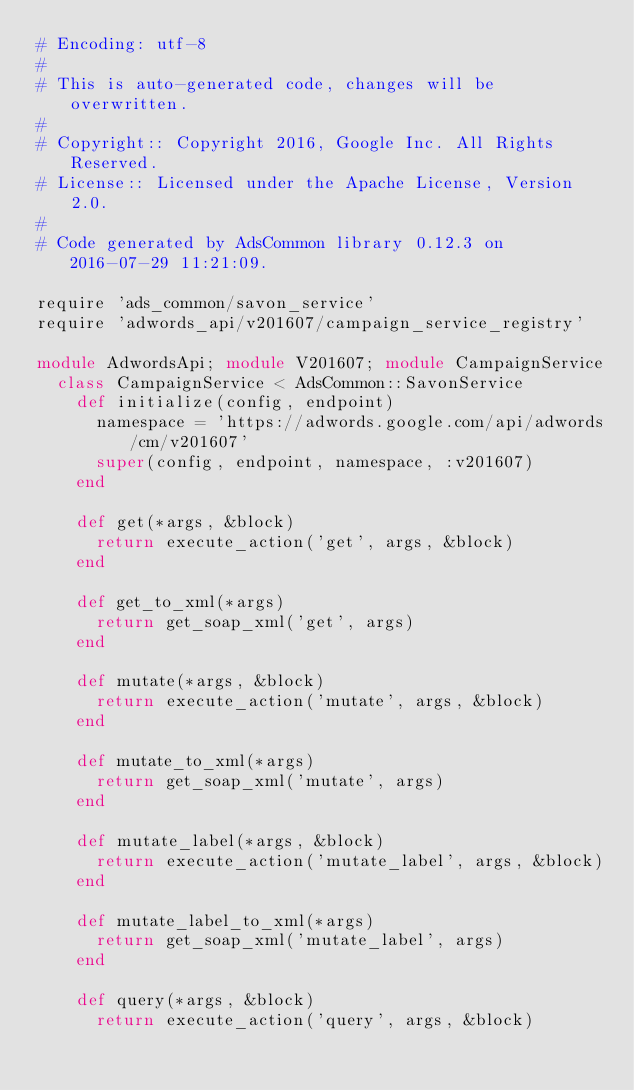<code> <loc_0><loc_0><loc_500><loc_500><_Ruby_># Encoding: utf-8
#
# This is auto-generated code, changes will be overwritten.
#
# Copyright:: Copyright 2016, Google Inc. All Rights Reserved.
# License:: Licensed under the Apache License, Version 2.0.
#
# Code generated by AdsCommon library 0.12.3 on 2016-07-29 11:21:09.

require 'ads_common/savon_service'
require 'adwords_api/v201607/campaign_service_registry'

module AdwordsApi; module V201607; module CampaignService
  class CampaignService < AdsCommon::SavonService
    def initialize(config, endpoint)
      namespace = 'https://adwords.google.com/api/adwords/cm/v201607'
      super(config, endpoint, namespace, :v201607)
    end

    def get(*args, &block)
      return execute_action('get', args, &block)
    end

    def get_to_xml(*args)
      return get_soap_xml('get', args)
    end

    def mutate(*args, &block)
      return execute_action('mutate', args, &block)
    end

    def mutate_to_xml(*args)
      return get_soap_xml('mutate', args)
    end

    def mutate_label(*args, &block)
      return execute_action('mutate_label', args, &block)
    end

    def mutate_label_to_xml(*args)
      return get_soap_xml('mutate_label', args)
    end

    def query(*args, &block)
      return execute_action('query', args, &block)</code> 